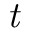Convert formula to latex. <formula><loc_0><loc_0><loc_500><loc_500>t</formula> 